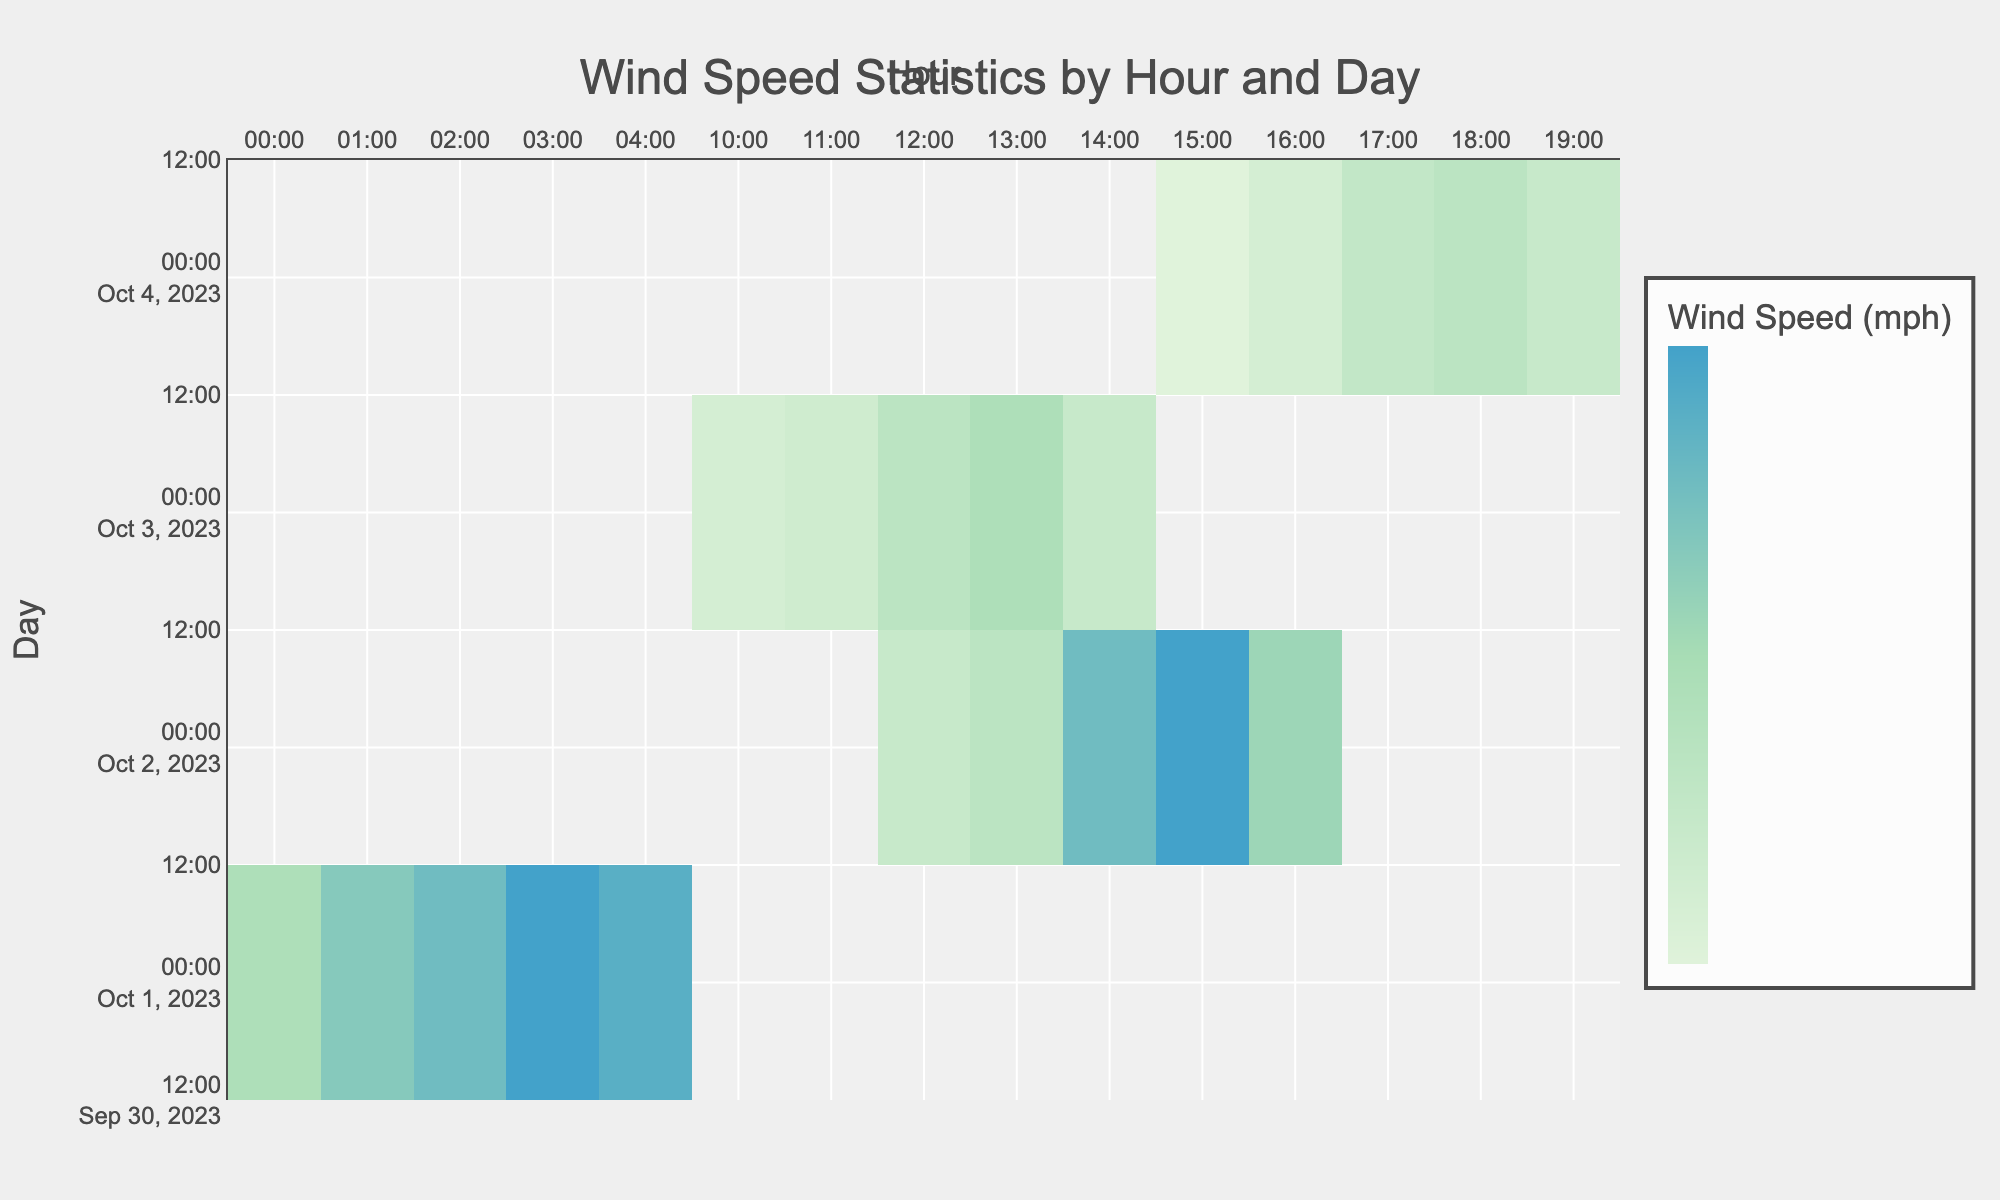What was the maximum wind speed recorded in Springfield? Looking at the table, the highest wind speed in Springfield occurred on October 1st at 03:00, which was 60 mph.
Answer: 60 mph What was the wind speed at 14:00 on October 2nd? The table shows that on October 2nd at 14:00 in Jacksonville, the wind speed was 50 mph.
Answer: 50 mph Which day had the highest average wind speed? To find the average, we calculate the wind speeds for each day and divide by the number of hours recorded. For October 1st: (35 + 45 + 50 + 60 + 55)/5 = 49 mph. For October 2nd: (25 + 30 + 50 + 60 + 40)/5 = 41 mph. For October 3rd: (20 + 22 + 30 + 35 + 25)/5 = 26.4 mph. For October 4th: (15 + 20 + 27 + 30 + 25)/5 = 23.4 mph. The highest average is 49 mph on October 1st.
Answer: October 1st Was there a recorded wind speed over 40 mph in Miami? In Miami, the maximum recorded wind speed is 35 mph on October 3rd at 13:00, which is below 40 mph.
Answer: No What is the difference in wind speed between the highest and lowest recorded speeds on October 4th? On October 4th, the highest wind speed is 30 mph at 18:00 and the lowest is 15 mph at 15:00. The difference is 30 - 15 = 15 mph.
Answer: 15 mph What was the total wind speed recorded in Jacksonville over the three hours from 14:00 to 16:00? The wind speeds in Jacksonville for the hours 14:00, 15:00, and 16:00 were 50, 60, and 40 mph respectively. Summing these gives: 50 + 60 + 40 = 150 mph.
Answer: 150 mph During which event type were the highest wind speeds observed? Referring to the highest recorded wind speeds, the tornado event on October 1st reached 60 mph, which is higher than any wind speeds during hurricane, thunderstorm, or dust storm events.
Answer: Tornado Which day had the least variation in wind speed? Looking at individual days, we calculate the range (max - min) for each day. October 1st has a range of 25 mph (60 - 35), October 2nd has a range of 35 mph (60 - 25), October 3rd has a range of 15 mph (35 - 20), and October 4th has a range of 15 mph (30 - 15). October 3rd had the least variation with a range of 15 mph.
Answer: October 3rd 